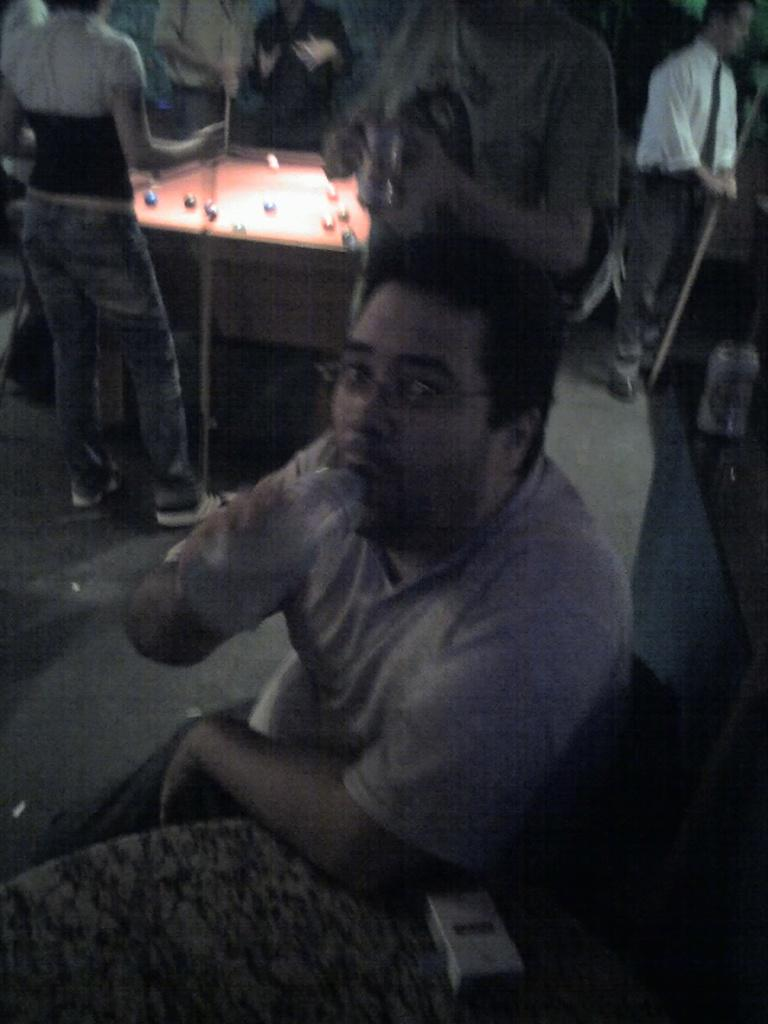What is the main object in the image? There is a billiard board in the image. Are there any people present in the image? Yes, there are people standing near the billiard board. What type of treatment is being administered to the button in the image? There is no button present in the image, and therefore no treatment can be administered to it. 